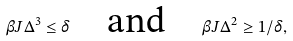Convert formula to latex. <formula><loc_0><loc_0><loc_500><loc_500>\beta J \Delta ^ { 3 } \leq \delta \quad \text {and} \quad \beta J \Delta ^ { 2 } \geq 1 / \delta ,</formula> 